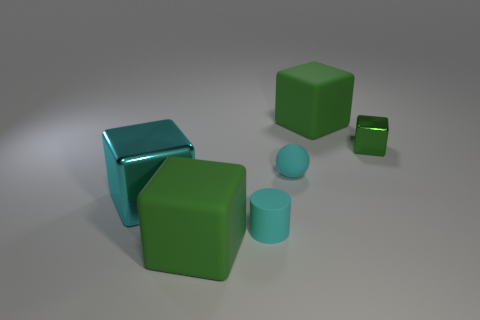Is the size of the cylinder the same as the cyan shiny thing?
Provide a succinct answer. No. What is the shape of the rubber object behind the small green shiny object?
Make the answer very short. Cube. Are there any cyan rubber cylinders of the same size as the cyan metallic object?
Your answer should be very brief. No. There is a cyan cylinder that is the same size as the green metal object; what is its material?
Ensure brevity in your answer.  Rubber. What is the size of the metal object left of the green shiny block?
Provide a succinct answer. Large. The cyan cube is what size?
Keep it short and to the point. Large. There is a cyan metal block; is its size the same as the green object to the left of the small cyan cylinder?
Keep it short and to the point. Yes. There is a thing to the left of the green rubber object that is on the left side of the cyan rubber cylinder; what is its color?
Give a very brief answer. Cyan. Are there an equal number of small green shiny blocks behind the green metallic cube and cyan metal objects right of the large cyan cube?
Offer a very short reply. Yes. Do the large thing in front of the tiny cylinder and the small green object have the same material?
Offer a very short reply. No. 